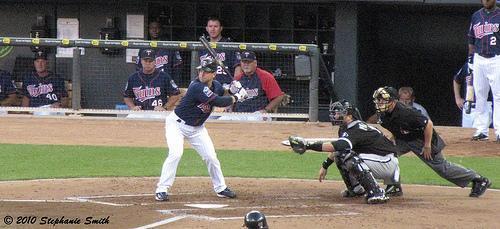How many people are in picture?
Give a very brief answer. 13. 